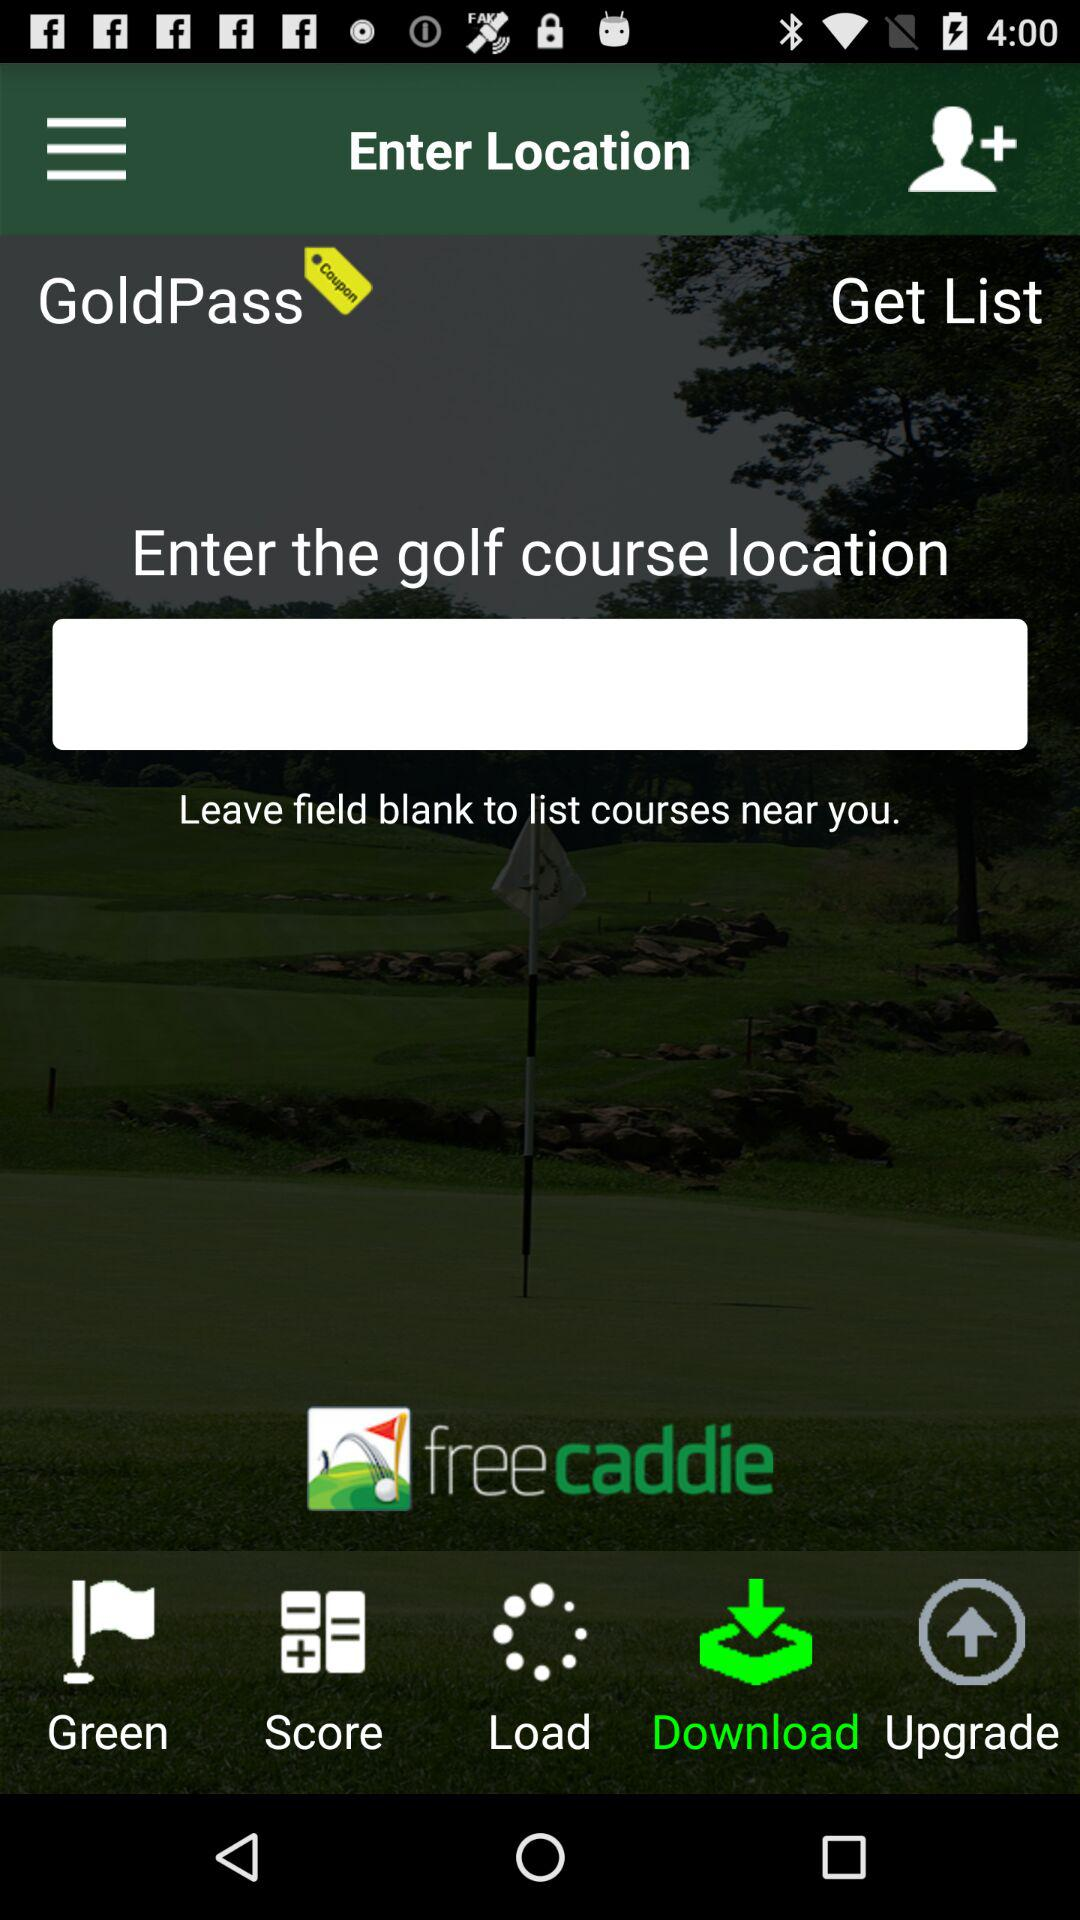What is the application name? The application name is "freecaddie". 